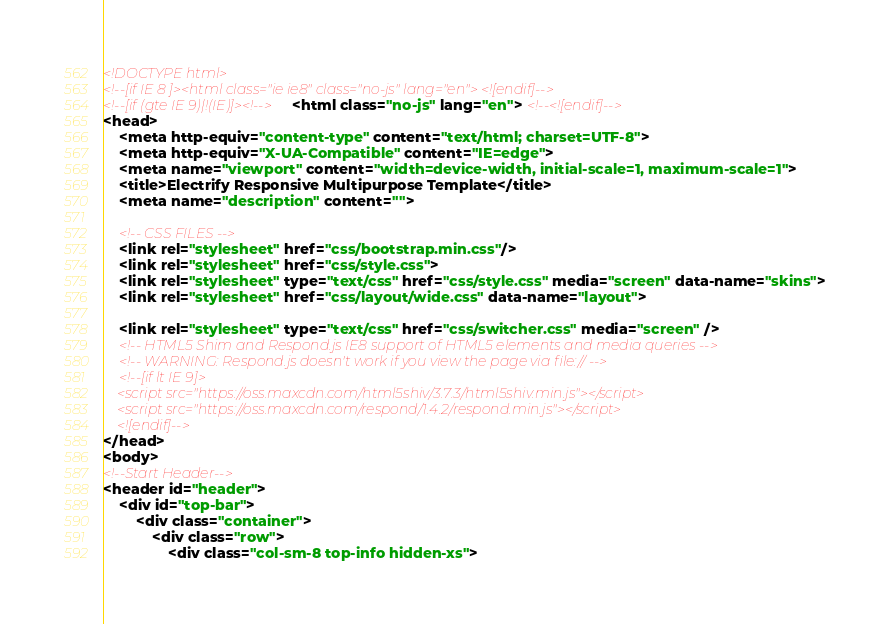<code> <loc_0><loc_0><loc_500><loc_500><_HTML_><!DOCTYPE html>
<!--[if IE 8 ]><html class="ie ie8" class="no-js" lang="en"> <![endif]-->
<!--[if (gte IE 9)|!(IE)]><!--><html class="no-js" lang="en"> <!--<![endif]-->
<head>
    <meta http-equiv="content-type" content="text/html; charset=UTF-8">
    <meta http-equiv="X-UA-Compatible" content="IE=edge">
    <meta name="viewport" content="width=device-width, initial-scale=1, maximum-scale=1">
    <title>Electrify Responsive Multipurpose Template</title>
    <meta name="description" content="">

    <!-- CSS FILES -->
    <link rel="stylesheet" href="css/bootstrap.min.css"/>
    <link rel="stylesheet" href="css/style.css">
    <link rel="stylesheet" type="text/css" href="css/style.css" media="screen" data-name="skins">
    <link rel="stylesheet" href="css/layout/wide.css" data-name="layout">

    <link rel="stylesheet" type="text/css" href="css/switcher.css" media="screen" />
    <!-- HTML5 Shim and Respond.js IE8 support of HTML5 elements and media queries -->
    <!-- WARNING: Respond.js doesn't work if you view the page via file:// -->
    <!--[if lt IE 9]>
    <script src="https://oss.maxcdn.com/html5shiv/3.7.3/html5shiv.min.js"></script>
    <script src="https://oss.maxcdn.com/respond/1.4.2/respond.min.js"></script>
    <![endif]-->
</head>
<body>
<!--Start Header-->
<header id="header">
    <div id="top-bar">
        <div class="container">
            <div class="row">
                <div class="col-sm-8 top-info hidden-xs"></code> 